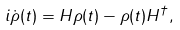<formula> <loc_0><loc_0><loc_500><loc_500>i \dot { \rho } ( t ) = H \rho ( t ) - \rho ( t ) H ^ { \dagger } ,</formula> 